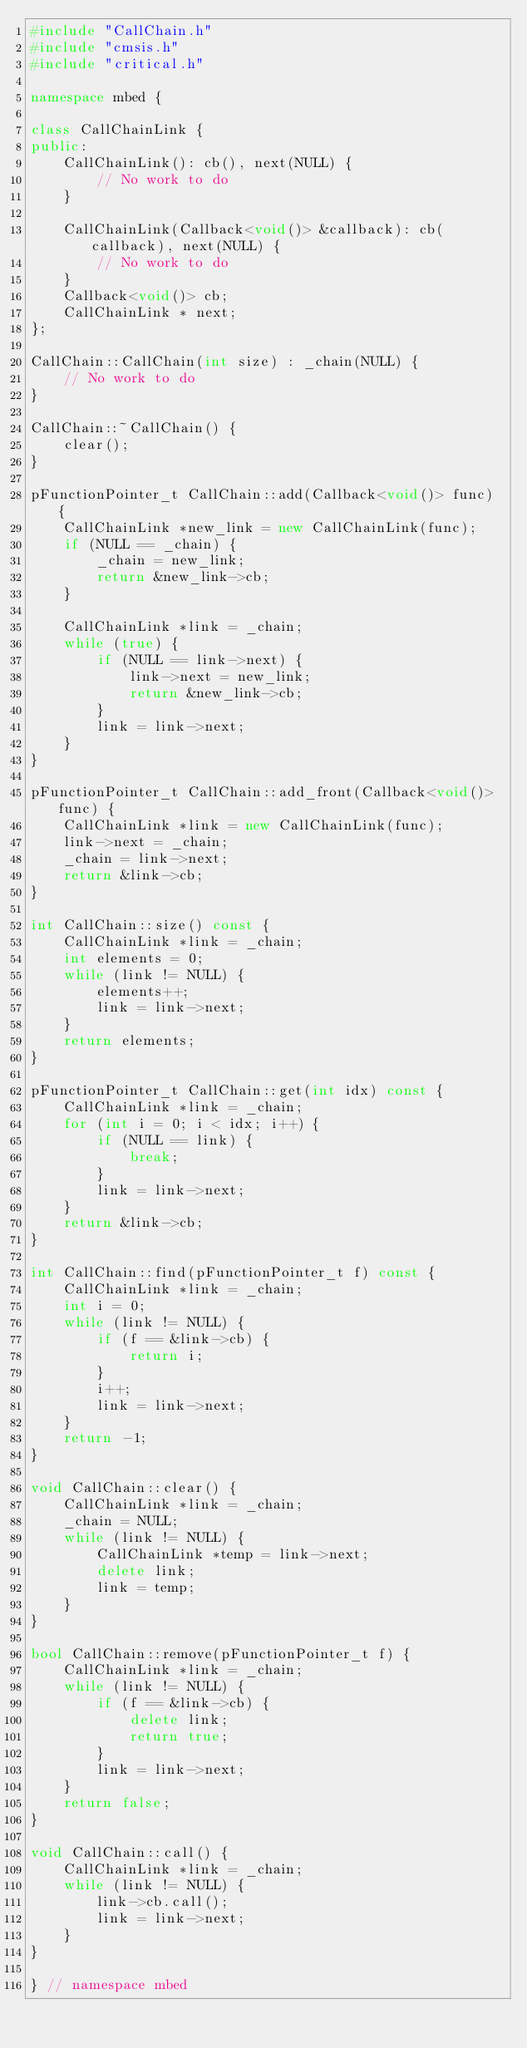<code> <loc_0><loc_0><loc_500><loc_500><_C++_>#include "CallChain.h"
#include "cmsis.h"
#include "critical.h"

namespace mbed {

class CallChainLink {
public:
    CallChainLink(): cb(), next(NULL) {
        // No work to do
    }

    CallChainLink(Callback<void()> &callback): cb(callback), next(NULL) {
        // No work to do
    }
    Callback<void()> cb;
    CallChainLink * next;
};

CallChain::CallChain(int size) : _chain(NULL) {
    // No work to do
}

CallChain::~CallChain() {
    clear();
}

pFunctionPointer_t CallChain::add(Callback<void()> func) {
    CallChainLink *new_link = new CallChainLink(func);
    if (NULL == _chain) {
        _chain = new_link;
        return &new_link->cb;
    }

    CallChainLink *link = _chain;
    while (true) {
        if (NULL == link->next) {
            link->next = new_link;
            return &new_link->cb;
        }
        link = link->next;
    }
}

pFunctionPointer_t CallChain::add_front(Callback<void()> func) {
    CallChainLink *link = new CallChainLink(func);
    link->next = _chain;
    _chain = link->next;
    return &link->cb;
}

int CallChain::size() const {
    CallChainLink *link = _chain;
    int elements = 0;
    while (link != NULL) {
        elements++;
        link = link->next;
    }
    return elements;
}

pFunctionPointer_t CallChain::get(int idx) const {
    CallChainLink *link = _chain;
    for (int i = 0; i < idx; i++) {
        if (NULL == link) {
            break;
        }
        link = link->next;
    }
    return &link->cb;
}

int CallChain::find(pFunctionPointer_t f) const {
    CallChainLink *link = _chain;
    int i = 0;
    while (link != NULL) {
        if (f == &link->cb) {
            return i;
        }
        i++;
        link = link->next;
    }
    return -1;
}

void CallChain::clear() {
    CallChainLink *link = _chain;
    _chain = NULL;
    while (link != NULL) {
        CallChainLink *temp = link->next;
        delete link;
        link = temp;
    }
}

bool CallChain::remove(pFunctionPointer_t f) {
    CallChainLink *link = _chain;
    while (link != NULL) {
        if (f == &link->cb) {
            delete link;
            return true;
        }
        link = link->next;
    }
    return false;
}

void CallChain::call() {
    CallChainLink *link = _chain;
    while (link != NULL) {
        link->cb.call();
        link = link->next;
    }
}

} // namespace mbed
</code> 